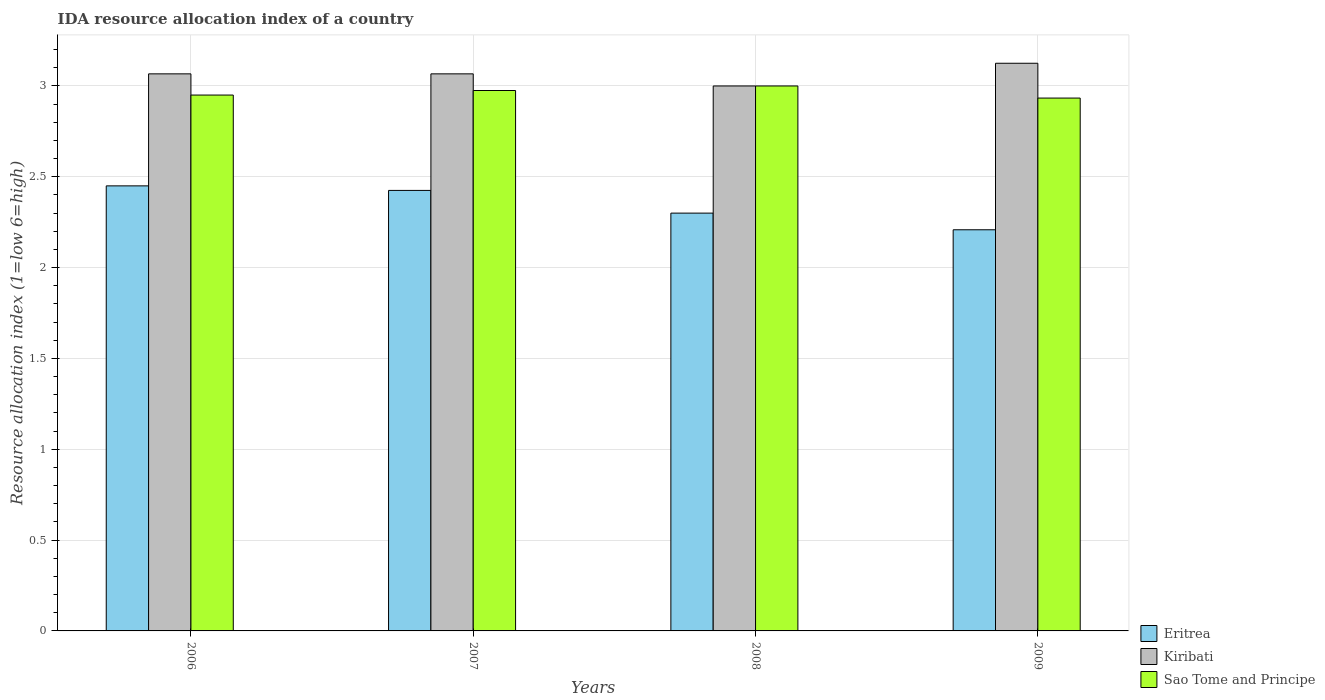How many different coloured bars are there?
Your answer should be compact. 3. Are the number of bars per tick equal to the number of legend labels?
Provide a short and direct response. Yes. Are the number of bars on each tick of the X-axis equal?
Keep it short and to the point. Yes. How many bars are there on the 3rd tick from the left?
Give a very brief answer. 3. What is the label of the 3rd group of bars from the left?
Keep it short and to the point. 2008. What is the IDA resource allocation index in Kiribati in 2006?
Your response must be concise. 3.07. Across all years, what is the minimum IDA resource allocation index in Kiribati?
Ensure brevity in your answer.  3. In which year was the IDA resource allocation index in Sao Tome and Principe maximum?
Provide a succinct answer. 2008. What is the total IDA resource allocation index in Eritrea in the graph?
Provide a short and direct response. 9.38. What is the difference between the IDA resource allocation index in Sao Tome and Principe in 2008 and that in 2009?
Ensure brevity in your answer.  0.07. What is the difference between the IDA resource allocation index in Kiribati in 2007 and the IDA resource allocation index in Sao Tome and Principe in 2008?
Provide a succinct answer. 0.07. What is the average IDA resource allocation index in Eritrea per year?
Offer a very short reply. 2.35. In the year 2008, what is the difference between the IDA resource allocation index in Sao Tome and Principe and IDA resource allocation index in Eritrea?
Provide a short and direct response. 0.7. What is the ratio of the IDA resource allocation index in Sao Tome and Principe in 2007 to that in 2008?
Provide a short and direct response. 0.99. Is the IDA resource allocation index in Eritrea in 2007 less than that in 2009?
Ensure brevity in your answer.  No. What is the difference between the highest and the second highest IDA resource allocation index in Kiribati?
Offer a terse response. 0.06. In how many years, is the IDA resource allocation index in Kiribati greater than the average IDA resource allocation index in Kiribati taken over all years?
Make the answer very short. 3. Is the sum of the IDA resource allocation index in Sao Tome and Principe in 2007 and 2009 greater than the maximum IDA resource allocation index in Kiribati across all years?
Keep it short and to the point. Yes. What does the 1st bar from the left in 2006 represents?
Keep it short and to the point. Eritrea. What does the 1st bar from the right in 2008 represents?
Your response must be concise. Sao Tome and Principe. Is it the case that in every year, the sum of the IDA resource allocation index in Sao Tome and Principe and IDA resource allocation index in Eritrea is greater than the IDA resource allocation index in Kiribati?
Your answer should be compact. Yes. How many bars are there?
Offer a terse response. 12. How many years are there in the graph?
Make the answer very short. 4. What is the difference between two consecutive major ticks on the Y-axis?
Provide a succinct answer. 0.5. Are the values on the major ticks of Y-axis written in scientific E-notation?
Your response must be concise. No. Does the graph contain grids?
Offer a very short reply. Yes. How are the legend labels stacked?
Provide a short and direct response. Vertical. What is the title of the graph?
Give a very brief answer. IDA resource allocation index of a country. What is the label or title of the X-axis?
Ensure brevity in your answer.  Years. What is the label or title of the Y-axis?
Provide a short and direct response. Resource allocation index (1=low 6=high). What is the Resource allocation index (1=low 6=high) in Eritrea in 2006?
Give a very brief answer. 2.45. What is the Resource allocation index (1=low 6=high) of Kiribati in 2006?
Give a very brief answer. 3.07. What is the Resource allocation index (1=low 6=high) in Sao Tome and Principe in 2006?
Make the answer very short. 2.95. What is the Resource allocation index (1=low 6=high) in Eritrea in 2007?
Ensure brevity in your answer.  2.42. What is the Resource allocation index (1=low 6=high) of Kiribati in 2007?
Your answer should be compact. 3.07. What is the Resource allocation index (1=low 6=high) in Sao Tome and Principe in 2007?
Your response must be concise. 2.98. What is the Resource allocation index (1=low 6=high) in Eritrea in 2008?
Provide a short and direct response. 2.3. What is the Resource allocation index (1=low 6=high) of Kiribati in 2008?
Ensure brevity in your answer.  3. What is the Resource allocation index (1=low 6=high) of Sao Tome and Principe in 2008?
Give a very brief answer. 3. What is the Resource allocation index (1=low 6=high) in Eritrea in 2009?
Give a very brief answer. 2.21. What is the Resource allocation index (1=low 6=high) in Kiribati in 2009?
Your response must be concise. 3.12. What is the Resource allocation index (1=low 6=high) of Sao Tome and Principe in 2009?
Offer a very short reply. 2.93. Across all years, what is the maximum Resource allocation index (1=low 6=high) in Eritrea?
Make the answer very short. 2.45. Across all years, what is the maximum Resource allocation index (1=low 6=high) of Kiribati?
Keep it short and to the point. 3.12. Across all years, what is the maximum Resource allocation index (1=low 6=high) in Sao Tome and Principe?
Your response must be concise. 3. Across all years, what is the minimum Resource allocation index (1=low 6=high) in Eritrea?
Offer a terse response. 2.21. Across all years, what is the minimum Resource allocation index (1=low 6=high) in Sao Tome and Principe?
Offer a terse response. 2.93. What is the total Resource allocation index (1=low 6=high) of Eritrea in the graph?
Give a very brief answer. 9.38. What is the total Resource allocation index (1=low 6=high) of Kiribati in the graph?
Provide a short and direct response. 12.26. What is the total Resource allocation index (1=low 6=high) in Sao Tome and Principe in the graph?
Give a very brief answer. 11.86. What is the difference between the Resource allocation index (1=low 6=high) in Eritrea in 2006 and that in 2007?
Your answer should be compact. 0.03. What is the difference between the Resource allocation index (1=low 6=high) in Sao Tome and Principe in 2006 and that in 2007?
Ensure brevity in your answer.  -0.03. What is the difference between the Resource allocation index (1=low 6=high) in Kiribati in 2006 and that in 2008?
Offer a terse response. 0.07. What is the difference between the Resource allocation index (1=low 6=high) of Sao Tome and Principe in 2006 and that in 2008?
Your response must be concise. -0.05. What is the difference between the Resource allocation index (1=low 6=high) of Eritrea in 2006 and that in 2009?
Your answer should be very brief. 0.24. What is the difference between the Resource allocation index (1=low 6=high) of Kiribati in 2006 and that in 2009?
Provide a succinct answer. -0.06. What is the difference between the Resource allocation index (1=low 6=high) of Sao Tome and Principe in 2006 and that in 2009?
Provide a succinct answer. 0.02. What is the difference between the Resource allocation index (1=low 6=high) of Eritrea in 2007 and that in 2008?
Provide a succinct answer. 0.12. What is the difference between the Resource allocation index (1=low 6=high) of Kiribati in 2007 and that in 2008?
Ensure brevity in your answer.  0.07. What is the difference between the Resource allocation index (1=low 6=high) in Sao Tome and Principe in 2007 and that in 2008?
Make the answer very short. -0.03. What is the difference between the Resource allocation index (1=low 6=high) in Eritrea in 2007 and that in 2009?
Keep it short and to the point. 0.22. What is the difference between the Resource allocation index (1=low 6=high) in Kiribati in 2007 and that in 2009?
Offer a terse response. -0.06. What is the difference between the Resource allocation index (1=low 6=high) in Sao Tome and Principe in 2007 and that in 2009?
Ensure brevity in your answer.  0.04. What is the difference between the Resource allocation index (1=low 6=high) in Eritrea in 2008 and that in 2009?
Offer a terse response. 0.09. What is the difference between the Resource allocation index (1=low 6=high) in Kiribati in 2008 and that in 2009?
Provide a short and direct response. -0.12. What is the difference between the Resource allocation index (1=low 6=high) of Sao Tome and Principe in 2008 and that in 2009?
Provide a succinct answer. 0.07. What is the difference between the Resource allocation index (1=low 6=high) in Eritrea in 2006 and the Resource allocation index (1=low 6=high) in Kiribati in 2007?
Provide a succinct answer. -0.62. What is the difference between the Resource allocation index (1=low 6=high) in Eritrea in 2006 and the Resource allocation index (1=low 6=high) in Sao Tome and Principe in 2007?
Your answer should be compact. -0.53. What is the difference between the Resource allocation index (1=low 6=high) in Kiribati in 2006 and the Resource allocation index (1=low 6=high) in Sao Tome and Principe in 2007?
Your answer should be compact. 0.09. What is the difference between the Resource allocation index (1=low 6=high) of Eritrea in 2006 and the Resource allocation index (1=low 6=high) of Kiribati in 2008?
Offer a terse response. -0.55. What is the difference between the Resource allocation index (1=low 6=high) in Eritrea in 2006 and the Resource allocation index (1=low 6=high) in Sao Tome and Principe in 2008?
Provide a short and direct response. -0.55. What is the difference between the Resource allocation index (1=low 6=high) in Kiribati in 2006 and the Resource allocation index (1=low 6=high) in Sao Tome and Principe in 2008?
Provide a succinct answer. 0.07. What is the difference between the Resource allocation index (1=low 6=high) of Eritrea in 2006 and the Resource allocation index (1=low 6=high) of Kiribati in 2009?
Give a very brief answer. -0.68. What is the difference between the Resource allocation index (1=low 6=high) in Eritrea in 2006 and the Resource allocation index (1=low 6=high) in Sao Tome and Principe in 2009?
Your response must be concise. -0.48. What is the difference between the Resource allocation index (1=low 6=high) in Kiribati in 2006 and the Resource allocation index (1=low 6=high) in Sao Tome and Principe in 2009?
Offer a very short reply. 0.13. What is the difference between the Resource allocation index (1=low 6=high) in Eritrea in 2007 and the Resource allocation index (1=low 6=high) in Kiribati in 2008?
Make the answer very short. -0.57. What is the difference between the Resource allocation index (1=low 6=high) in Eritrea in 2007 and the Resource allocation index (1=low 6=high) in Sao Tome and Principe in 2008?
Provide a succinct answer. -0.57. What is the difference between the Resource allocation index (1=low 6=high) of Kiribati in 2007 and the Resource allocation index (1=low 6=high) of Sao Tome and Principe in 2008?
Keep it short and to the point. 0.07. What is the difference between the Resource allocation index (1=low 6=high) of Eritrea in 2007 and the Resource allocation index (1=low 6=high) of Sao Tome and Principe in 2009?
Your response must be concise. -0.51. What is the difference between the Resource allocation index (1=low 6=high) of Kiribati in 2007 and the Resource allocation index (1=low 6=high) of Sao Tome and Principe in 2009?
Offer a very short reply. 0.13. What is the difference between the Resource allocation index (1=low 6=high) of Eritrea in 2008 and the Resource allocation index (1=low 6=high) of Kiribati in 2009?
Give a very brief answer. -0.82. What is the difference between the Resource allocation index (1=low 6=high) of Eritrea in 2008 and the Resource allocation index (1=low 6=high) of Sao Tome and Principe in 2009?
Make the answer very short. -0.63. What is the difference between the Resource allocation index (1=low 6=high) in Kiribati in 2008 and the Resource allocation index (1=low 6=high) in Sao Tome and Principe in 2009?
Provide a succinct answer. 0.07. What is the average Resource allocation index (1=low 6=high) in Eritrea per year?
Provide a succinct answer. 2.35. What is the average Resource allocation index (1=low 6=high) in Kiribati per year?
Provide a succinct answer. 3.06. What is the average Resource allocation index (1=low 6=high) of Sao Tome and Principe per year?
Your answer should be very brief. 2.96. In the year 2006, what is the difference between the Resource allocation index (1=low 6=high) in Eritrea and Resource allocation index (1=low 6=high) in Kiribati?
Your response must be concise. -0.62. In the year 2006, what is the difference between the Resource allocation index (1=low 6=high) in Eritrea and Resource allocation index (1=low 6=high) in Sao Tome and Principe?
Offer a very short reply. -0.5. In the year 2006, what is the difference between the Resource allocation index (1=low 6=high) of Kiribati and Resource allocation index (1=low 6=high) of Sao Tome and Principe?
Your response must be concise. 0.12. In the year 2007, what is the difference between the Resource allocation index (1=low 6=high) of Eritrea and Resource allocation index (1=low 6=high) of Kiribati?
Ensure brevity in your answer.  -0.64. In the year 2007, what is the difference between the Resource allocation index (1=low 6=high) of Eritrea and Resource allocation index (1=low 6=high) of Sao Tome and Principe?
Provide a short and direct response. -0.55. In the year 2007, what is the difference between the Resource allocation index (1=low 6=high) of Kiribati and Resource allocation index (1=low 6=high) of Sao Tome and Principe?
Provide a short and direct response. 0.09. In the year 2008, what is the difference between the Resource allocation index (1=low 6=high) in Eritrea and Resource allocation index (1=low 6=high) in Kiribati?
Your answer should be very brief. -0.7. In the year 2008, what is the difference between the Resource allocation index (1=low 6=high) of Kiribati and Resource allocation index (1=low 6=high) of Sao Tome and Principe?
Give a very brief answer. 0. In the year 2009, what is the difference between the Resource allocation index (1=low 6=high) of Eritrea and Resource allocation index (1=low 6=high) of Kiribati?
Ensure brevity in your answer.  -0.92. In the year 2009, what is the difference between the Resource allocation index (1=low 6=high) of Eritrea and Resource allocation index (1=low 6=high) of Sao Tome and Principe?
Your answer should be very brief. -0.72. In the year 2009, what is the difference between the Resource allocation index (1=low 6=high) in Kiribati and Resource allocation index (1=low 6=high) in Sao Tome and Principe?
Give a very brief answer. 0.19. What is the ratio of the Resource allocation index (1=low 6=high) in Eritrea in 2006 to that in 2007?
Make the answer very short. 1.01. What is the ratio of the Resource allocation index (1=low 6=high) in Sao Tome and Principe in 2006 to that in 2007?
Ensure brevity in your answer.  0.99. What is the ratio of the Resource allocation index (1=low 6=high) of Eritrea in 2006 to that in 2008?
Make the answer very short. 1.07. What is the ratio of the Resource allocation index (1=low 6=high) of Kiribati in 2006 to that in 2008?
Offer a terse response. 1.02. What is the ratio of the Resource allocation index (1=low 6=high) in Sao Tome and Principe in 2006 to that in 2008?
Keep it short and to the point. 0.98. What is the ratio of the Resource allocation index (1=low 6=high) in Eritrea in 2006 to that in 2009?
Give a very brief answer. 1.11. What is the ratio of the Resource allocation index (1=low 6=high) in Kiribati in 2006 to that in 2009?
Your response must be concise. 0.98. What is the ratio of the Resource allocation index (1=low 6=high) in Eritrea in 2007 to that in 2008?
Your answer should be very brief. 1.05. What is the ratio of the Resource allocation index (1=low 6=high) in Kiribati in 2007 to that in 2008?
Offer a terse response. 1.02. What is the ratio of the Resource allocation index (1=low 6=high) in Sao Tome and Principe in 2007 to that in 2008?
Give a very brief answer. 0.99. What is the ratio of the Resource allocation index (1=low 6=high) in Eritrea in 2007 to that in 2009?
Make the answer very short. 1.1. What is the ratio of the Resource allocation index (1=low 6=high) of Kiribati in 2007 to that in 2009?
Give a very brief answer. 0.98. What is the ratio of the Resource allocation index (1=low 6=high) of Sao Tome and Principe in 2007 to that in 2009?
Provide a succinct answer. 1.01. What is the ratio of the Resource allocation index (1=low 6=high) in Eritrea in 2008 to that in 2009?
Offer a terse response. 1.04. What is the ratio of the Resource allocation index (1=low 6=high) in Sao Tome and Principe in 2008 to that in 2009?
Your answer should be very brief. 1.02. What is the difference between the highest and the second highest Resource allocation index (1=low 6=high) of Eritrea?
Ensure brevity in your answer.  0.03. What is the difference between the highest and the second highest Resource allocation index (1=low 6=high) in Kiribati?
Your answer should be compact. 0.06. What is the difference between the highest and the second highest Resource allocation index (1=low 6=high) in Sao Tome and Principe?
Provide a short and direct response. 0.03. What is the difference between the highest and the lowest Resource allocation index (1=low 6=high) of Eritrea?
Offer a terse response. 0.24. What is the difference between the highest and the lowest Resource allocation index (1=low 6=high) of Sao Tome and Principe?
Provide a succinct answer. 0.07. 